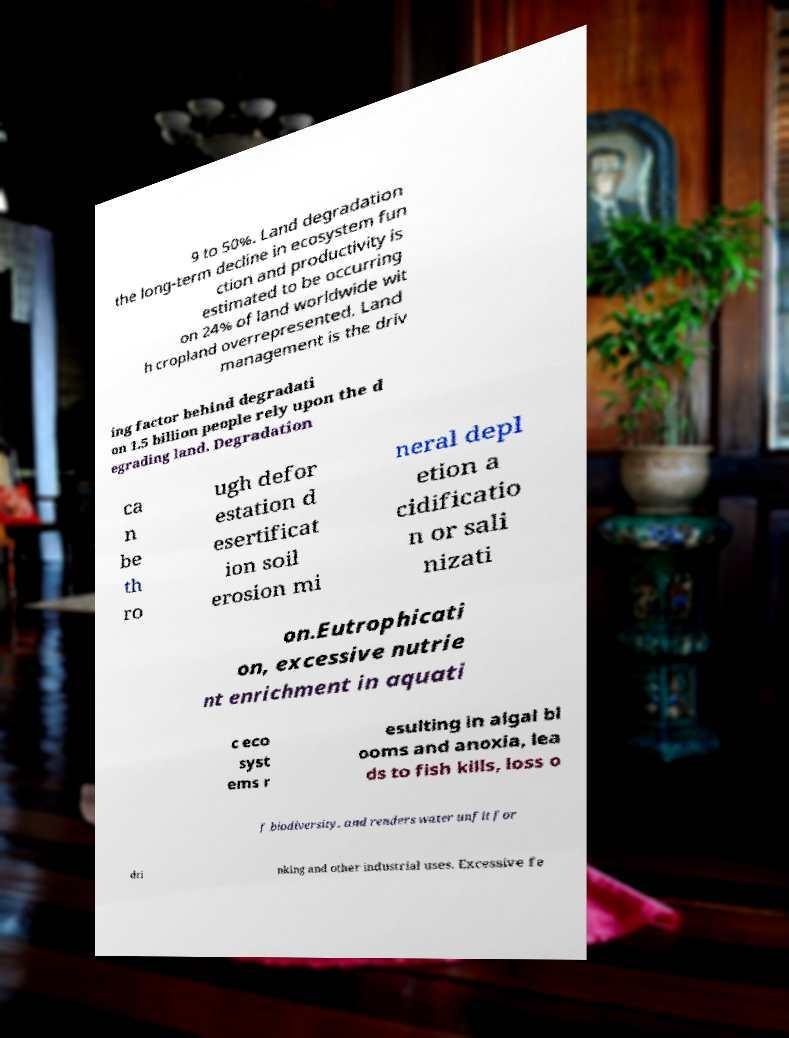For documentation purposes, I need the text within this image transcribed. Could you provide that? 9 to 50%. Land degradation the long-term decline in ecosystem fun ction and productivity is estimated to be occurring on 24% of land worldwide wit h cropland overrepresented. Land management is the driv ing factor behind degradati on 1.5 billion people rely upon the d egrading land. Degradation ca n be th ro ugh defor estation d esertificat ion soil erosion mi neral depl etion a cidificatio n or sali nizati on.Eutrophicati on, excessive nutrie nt enrichment in aquati c eco syst ems r esulting in algal bl ooms and anoxia, lea ds to fish kills, loss o f biodiversity, and renders water unfit for dri nking and other industrial uses. Excessive fe 